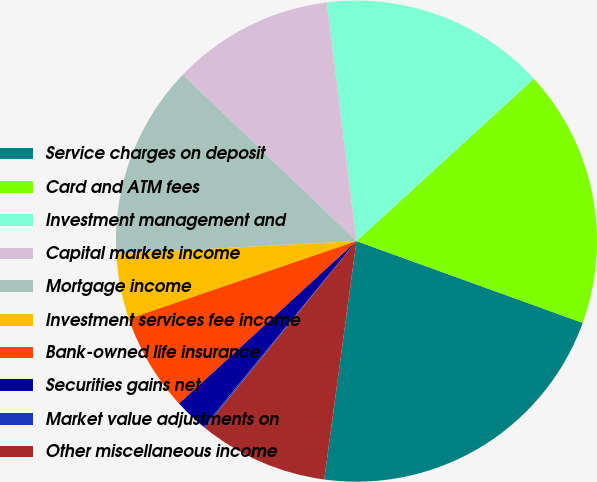Convert chart to OTSL. <chart><loc_0><loc_0><loc_500><loc_500><pie_chart><fcel>Service charges on deposit<fcel>Card and ATM fees<fcel>Investment management and<fcel>Capital markets income<fcel>Mortgage income<fcel>Investment services fee income<fcel>Bank-owned life insurance<fcel>Securities gains net<fcel>Market value adjustments on<fcel>Other miscellaneous income<nl><fcel>21.62%<fcel>17.32%<fcel>15.17%<fcel>10.86%<fcel>13.01%<fcel>4.4%<fcel>6.56%<fcel>2.25%<fcel>0.1%<fcel>8.71%<nl></chart> 